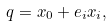<formula> <loc_0><loc_0><loc_500><loc_500>q = x _ { 0 } + e _ { i } x _ { i } ,</formula> 